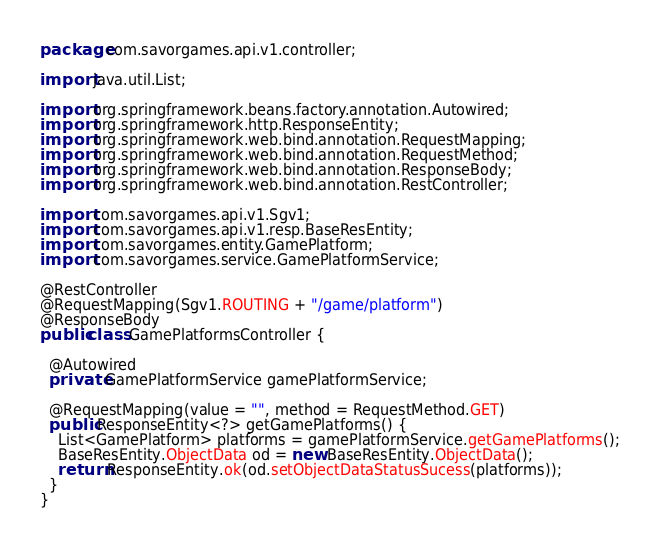<code> <loc_0><loc_0><loc_500><loc_500><_Java_>package com.savorgames.api.v1.controller;

import java.util.List;

import org.springframework.beans.factory.annotation.Autowired;
import org.springframework.http.ResponseEntity;
import org.springframework.web.bind.annotation.RequestMapping;
import org.springframework.web.bind.annotation.RequestMethod;
import org.springframework.web.bind.annotation.ResponseBody;
import org.springframework.web.bind.annotation.RestController;

import com.savorgames.api.v1.Sgv1;
import com.savorgames.api.v1.resp.BaseResEntity;
import com.savorgames.entity.GamePlatform;
import com.savorgames.service.GamePlatformService;

@RestController
@RequestMapping(Sgv1.ROUTING + "/game/platform")
@ResponseBody
public class GamePlatformsController {
  
  @Autowired
  private GamePlatformService gamePlatformService;
  
  @RequestMapping(value = "", method = RequestMethod.GET)
  public ResponseEntity<?> getGamePlatforms() {
    List<GamePlatform> platforms = gamePlatformService.getGamePlatforms();
    BaseResEntity.ObjectData od = new BaseResEntity.ObjectData();
    return ResponseEntity.ok(od.setObjectDataStatusSucess(platforms));
  }
}
</code> 